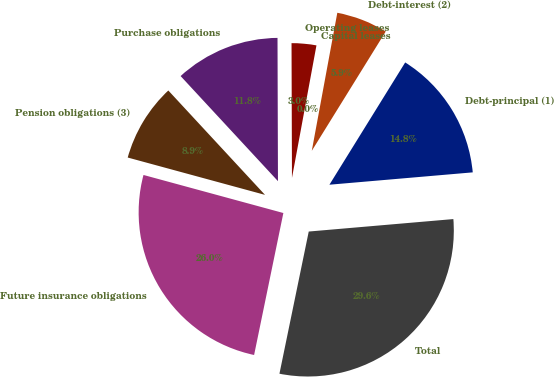Convert chart to OTSL. <chart><loc_0><loc_0><loc_500><loc_500><pie_chart><fcel>Debt-principal (1)<fcel>Debt-interest (2)<fcel>Capital leases<fcel>Operating leases<fcel>Purchase obligations<fcel>Pension obligations (3)<fcel>Future insurance obligations<fcel>Total<nl><fcel>14.8%<fcel>5.92%<fcel>0.0%<fcel>2.96%<fcel>11.84%<fcel>8.88%<fcel>25.99%<fcel>29.6%<nl></chart> 